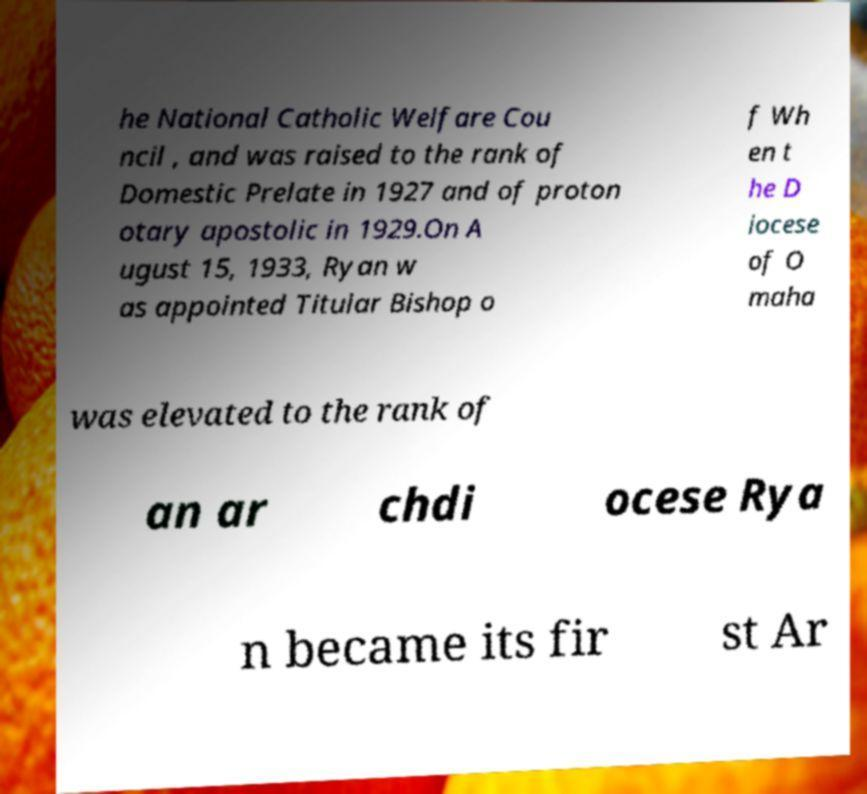For documentation purposes, I need the text within this image transcribed. Could you provide that? he National Catholic Welfare Cou ncil , and was raised to the rank of Domestic Prelate in 1927 and of proton otary apostolic in 1929.On A ugust 15, 1933, Ryan w as appointed Titular Bishop o f Wh en t he D iocese of O maha was elevated to the rank of an ar chdi ocese Rya n became its fir st Ar 